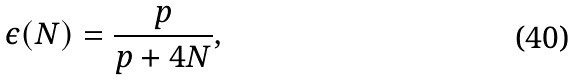<formula> <loc_0><loc_0><loc_500><loc_500>\epsilon ( N ) = \frac { p } { p + 4 N } ,</formula> 